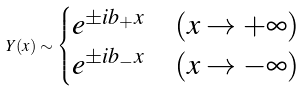Convert formula to latex. <formula><loc_0><loc_0><loc_500><loc_500>Y ( x ) \sim \begin{cases} e ^ { \pm i b _ { + } x } & ( x \to + \infty ) \\ e ^ { \pm i b _ { - } x } & ( x \to - \infty ) \end{cases}</formula> 